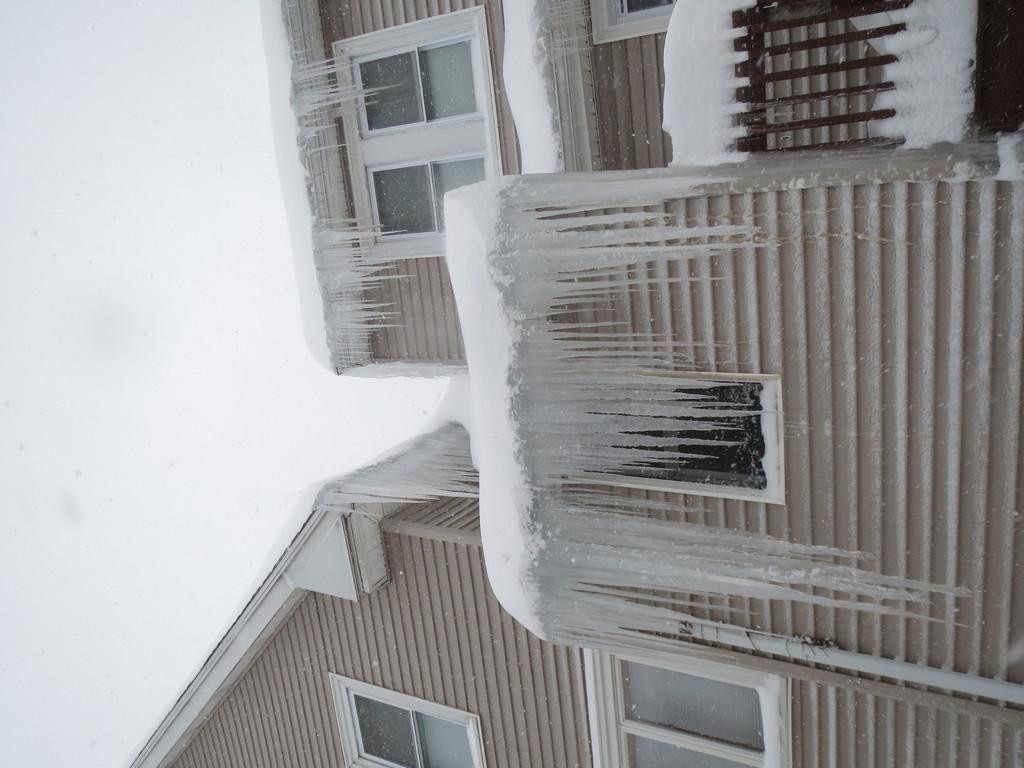How would you summarize this image in a sentence or two? In this image in front there are buildings, glass windows, metal fence and we can see snow on them. In the background of the image there is sky. 